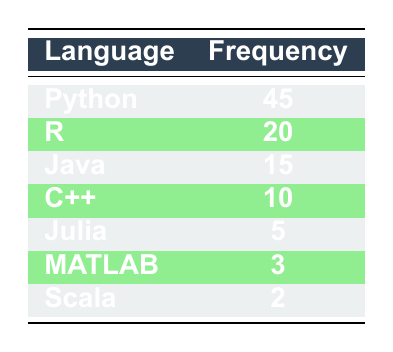What is the most frequently used programming language in AI projects according to the table? The table lists the frequencies of different programming languages used in AI projects. Python is the language with the highest frequency at 45.
Answer: Python How many programming languages have a frequency of 10 or more? Looking at the table, Python (45), R (20), Java (15), and C++ (10) all have frequencies of 10 or more. This makes a total of 4 programming languages.
Answer: 4 What is the total frequency of all programming languages listed? To find the total frequency, we add up the frequencies: 45 (Python) + 20 (R) + 15 (Java) + 10 (C++) + 5 (Julia) + 3 (MATLAB) + 2 (Scala) = 100.
Answer: 100 Is MATLAB the least used programming language in AI projects? Recognizing that MATLAB has a frequency of 3, and Scala has a frequency of 2, we see that MATLAB is not the least used language. Scala is.
Answer: No What is the frequency difference between Python and the second most used programming language? The second most used language is R with a frequency of 20. The difference between Python's frequency (45) and R's frequency (20) is 45 - 20 = 25.
Answer: 25 What is the average frequency of the languages in the table? To calculate the average, we sum the frequencies (100) and divide by the number of programming languages (7). Thus, the average is 100/7 ≈ 14.29.
Answer: Approximately 14.29 Does the table suggest that C++ is more popular than Julia in AI projects? Since C++ has a frequency of 10 while Julia has a frequency of 5, this indicates that C++ is indeed more popular than Julia in AI projects.
Answer: Yes Which programming language has the second-lowest frequency, and what is that frequency? By inspecting the table, we see that MATLAB has a frequency of 3 and Scala has a frequency of 2. Hence, MATLAB is the second-lowest with a frequency of 3.
Answer: MATLAB, 3 